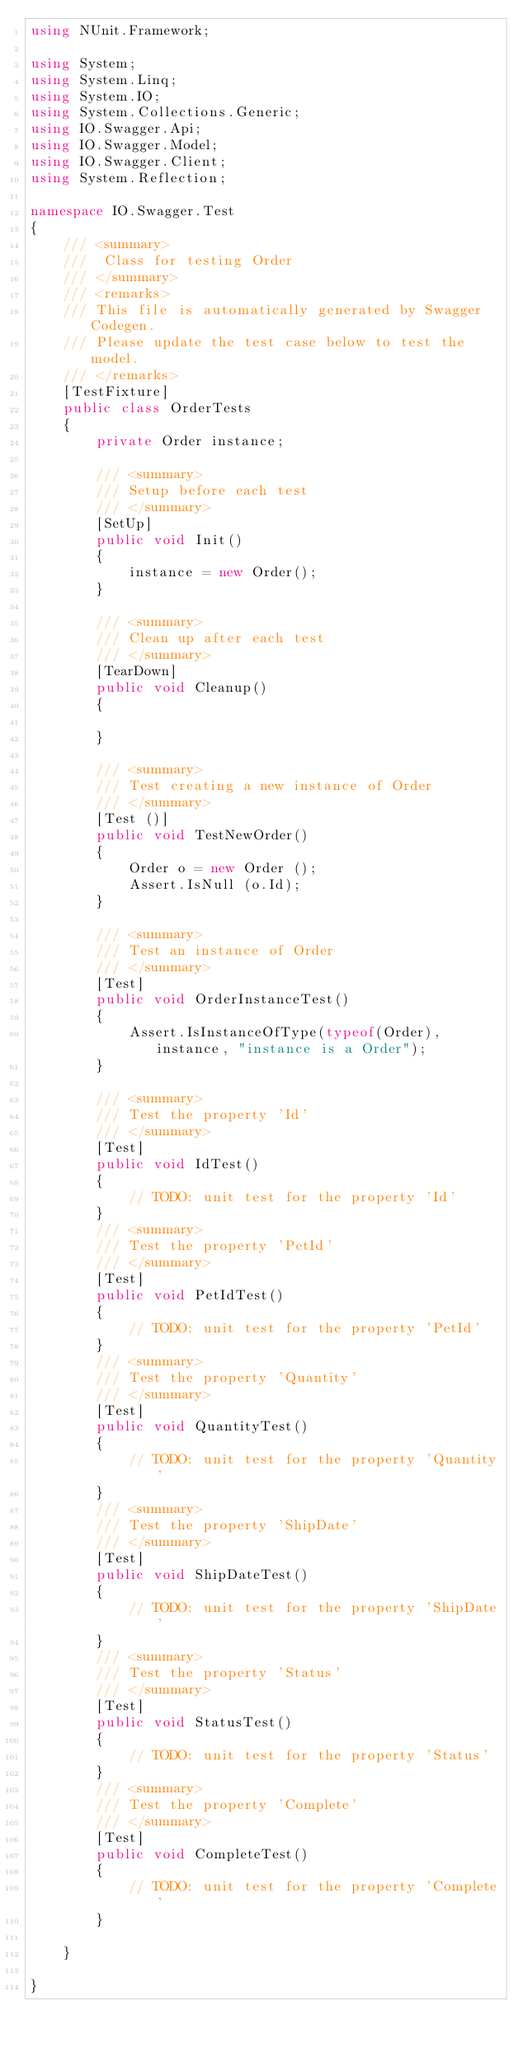<code> <loc_0><loc_0><loc_500><loc_500><_C#_>using NUnit.Framework;

using System;
using System.Linq;
using System.IO;
using System.Collections.Generic;
using IO.Swagger.Api;
using IO.Swagger.Model;
using IO.Swagger.Client;
using System.Reflection;

namespace IO.Swagger.Test
{
    /// <summary>
    ///  Class for testing Order
    /// </summary>
    /// <remarks>
    /// This file is automatically generated by Swagger Codegen.
    /// Please update the test case below to test the model.
    /// </remarks>
    [TestFixture]
    public class OrderTests
    {
        private Order instance;

        /// <summary>
        /// Setup before each test
        /// </summary>
        [SetUp]
        public void Init()
        {
            instance = new Order();
        }

        /// <summary>
        /// Clean up after each test
        /// </summary>
        [TearDown]
        public void Cleanup()
        {

        }

		/// <summary>
		/// Test creating a new instance of Order
		/// </summary>
		[Test ()]
		public void TestNewOrder()
		{
			Order o = new Order ();
			Assert.IsNull (o.Id);
		}

        /// <summary>
        /// Test an instance of Order
        /// </summary>
        [Test]
        public void OrderInstanceTest()
        {
			Assert.IsInstanceOfType(typeof(Order), instance, "instance is a Order");
        }

        /// <summary>
        /// Test the property 'Id'
        /// </summary>
        [Test]
        public void IdTest()
        {
            // TODO: unit test for the property 'Id'
        }
        /// <summary>
        /// Test the property 'PetId'
        /// </summary>
        [Test]
        public void PetIdTest()
        {
            // TODO: unit test for the property 'PetId'
        }
        /// <summary>
        /// Test the property 'Quantity'
        /// </summary>
        [Test]
        public void QuantityTest()
        {
            // TODO: unit test for the property 'Quantity'
        }
        /// <summary>
        /// Test the property 'ShipDate'
        /// </summary>
        [Test]
        public void ShipDateTest()
        {
            // TODO: unit test for the property 'ShipDate'
        }
        /// <summary>
        /// Test the property 'Status'
        /// </summary>
        [Test]
        public void StatusTest()
        {
            // TODO: unit test for the property 'Status'
        }
        /// <summary>
        /// Test the property 'Complete'
        /// </summary>
        [Test]
        public void CompleteTest()
        {
            // TODO: unit test for the property 'Complete'
        }

    }

}
</code> 